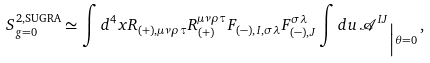Convert formula to latex. <formula><loc_0><loc_0><loc_500><loc_500>S _ { g = 0 } ^ { 2 , \text {SUGRA} } & \simeq \int d ^ { 4 } x R _ { ( + ) , \mu \nu \rho \tau } R _ { ( + ) } ^ { \mu \nu \rho \tau } F _ { ( - ) , I , \sigma \lambda } F _ { ( - ) , J } ^ { \sigma \lambda } \int d u \, { \mathcal { A } ^ { I J } } _ { \Big | \theta = 0 } \, ,</formula> 